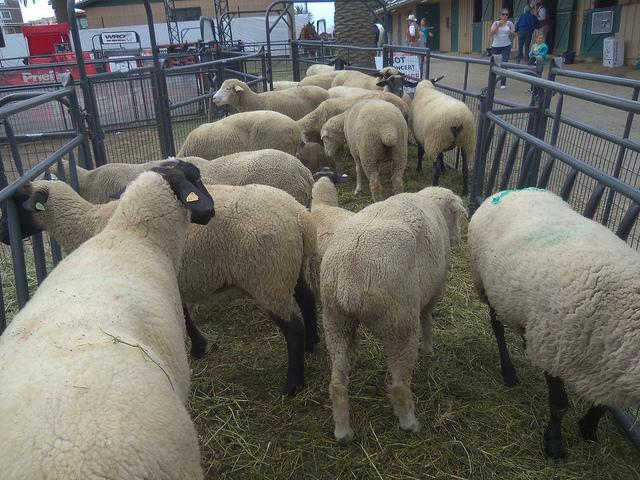What feature do these animals have? wool 